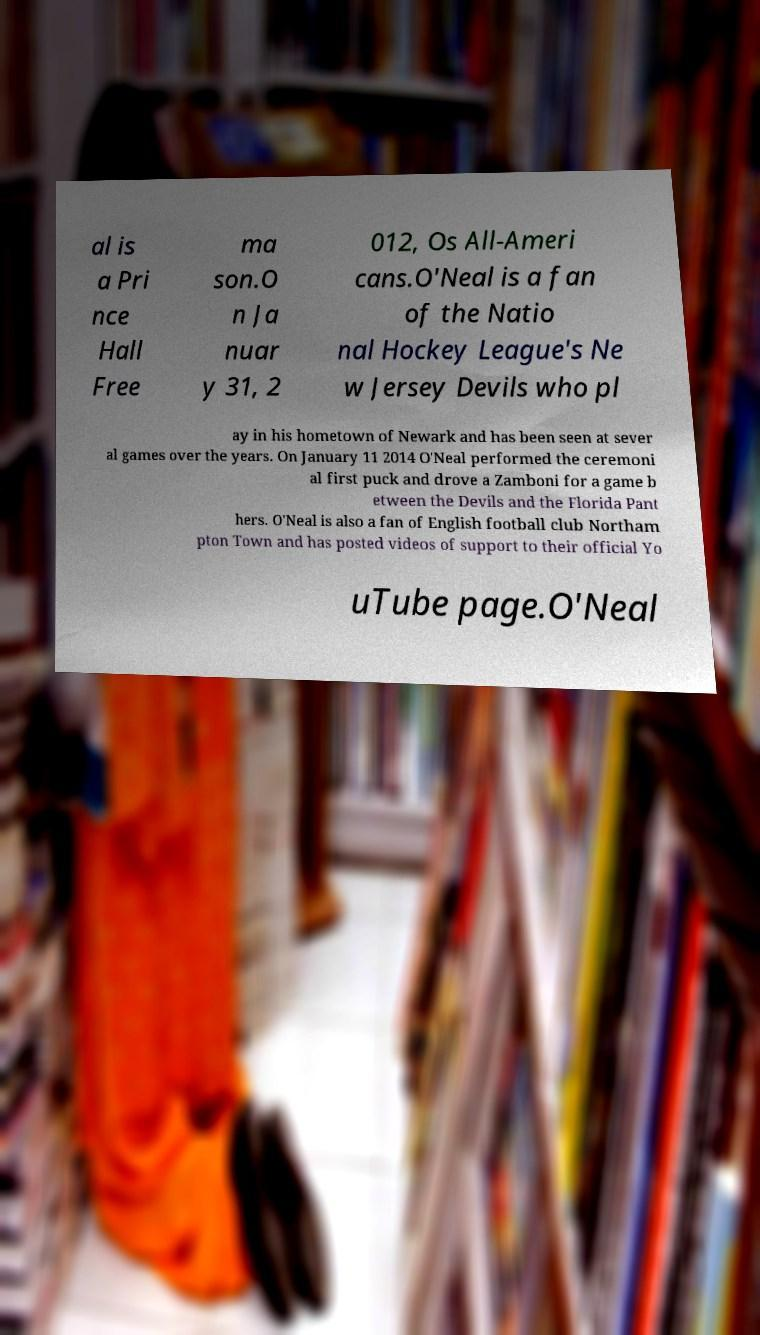For documentation purposes, I need the text within this image transcribed. Could you provide that? al is a Pri nce Hall Free ma son.O n Ja nuar y 31, 2 012, Os All-Ameri cans.O'Neal is a fan of the Natio nal Hockey League's Ne w Jersey Devils who pl ay in his hometown of Newark and has been seen at sever al games over the years. On January 11 2014 O'Neal performed the ceremoni al first puck and drove a Zamboni for a game b etween the Devils and the Florida Pant hers. O'Neal is also a fan of English football club Northam pton Town and has posted videos of support to their official Yo uTube page.O'Neal 